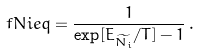<formula> <loc_0><loc_0><loc_500><loc_500>\ f N i e q = \frac { 1 } { \exp [ E _ { \widetilde { N _ { i } } } / T ] - 1 } \, .</formula> 